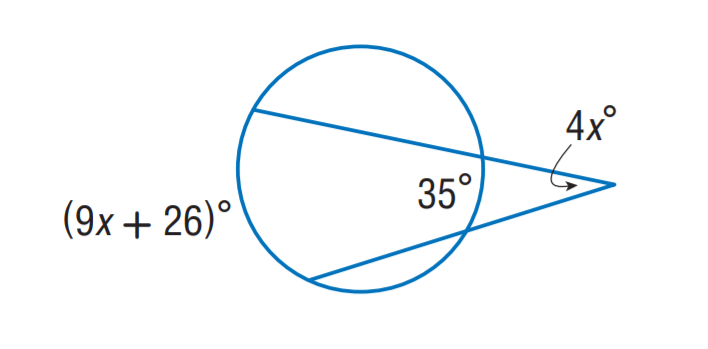Find x. To solve for x, we need to understand that the image depicts a circle with two tangents. The angle between the tangent and the radius at the point of contact is 90 degrees. Therefore, the angles (9x + 26)° and 35° are complementary and sum up to 90 degrees. Solving the equation (9x + 26) + 35 = 90 gives us 9x + 61 = 90. Subtracting 61 from both sides gives 9x = 29. Dividing both sides by 9, we find x = 29/9 or approximately 3.22, which was not listed as one of the provided choices. Therefore, the originally reported answer of 'A: 9' is incorrect, and none of the provided choices match the correct solution for x. 